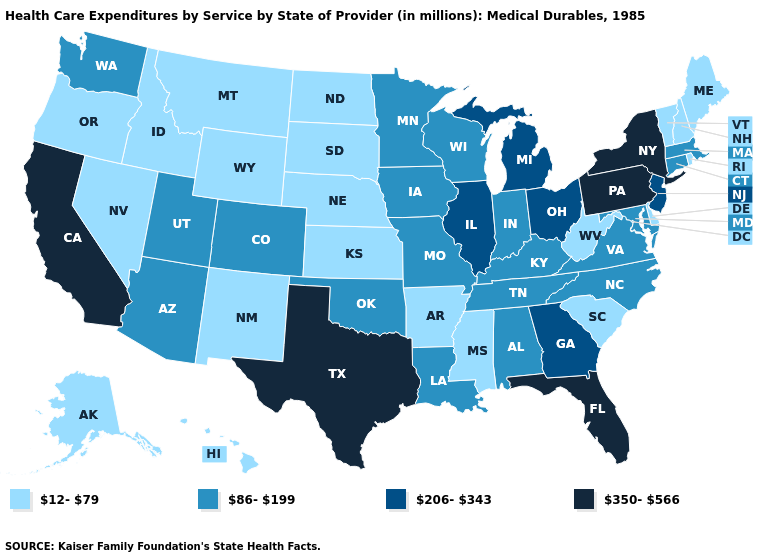Does Nevada have a lower value than Connecticut?
Give a very brief answer. Yes. What is the value of Louisiana?
Be succinct. 86-199. Which states have the lowest value in the USA?
Be succinct. Alaska, Arkansas, Delaware, Hawaii, Idaho, Kansas, Maine, Mississippi, Montana, Nebraska, Nevada, New Hampshire, New Mexico, North Dakota, Oregon, Rhode Island, South Carolina, South Dakota, Vermont, West Virginia, Wyoming. What is the lowest value in states that border Oklahoma?
Write a very short answer. 12-79. Which states have the lowest value in the Northeast?
Keep it brief. Maine, New Hampshire, Rhode Island, Vermont. Name the states that have a value in the range 206-343?
Be succinct. Georgia, Illinois, Michigan, New Jersey, Ohio. Which states have the lowest value in the South?
Give a very brief answer. Arkansas, Delaware, Mississippi, South Carolina, West Virginia. Among the states that border Vermont , which have the highest value?
Short answer required. New York. Does Illinois have the highest value in the MidWest?
Give a very brief answer. Yes. What is the value of Minnesota?
Keep it brief. 86-199. What is the value of Vermont?
Write a very short answer. 12-79. What is the value of Wisconsin?
Answer briefly. 86-199. Which states have the highest value in the USA?
Keep it brief. California, Florida, New York, Pennsylvania, Texas. Among the states that border Nevada , which have the highest value?
Answer briefly. California. What is the lowest value in the Northeast?
Give a very brief answer. 12-79. 